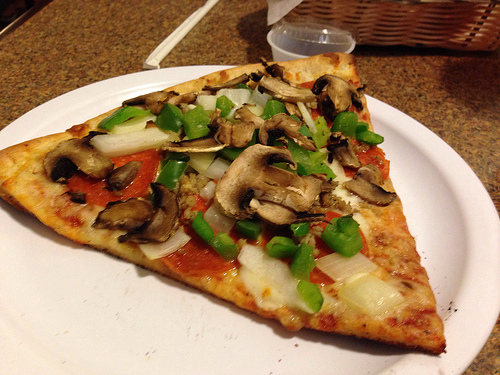Please provide a short description for this region: [0.32, 0.34, 0.51, 0.45]. This zone of the image includes a segment of a pizza topped with sautéed mushrooms. 